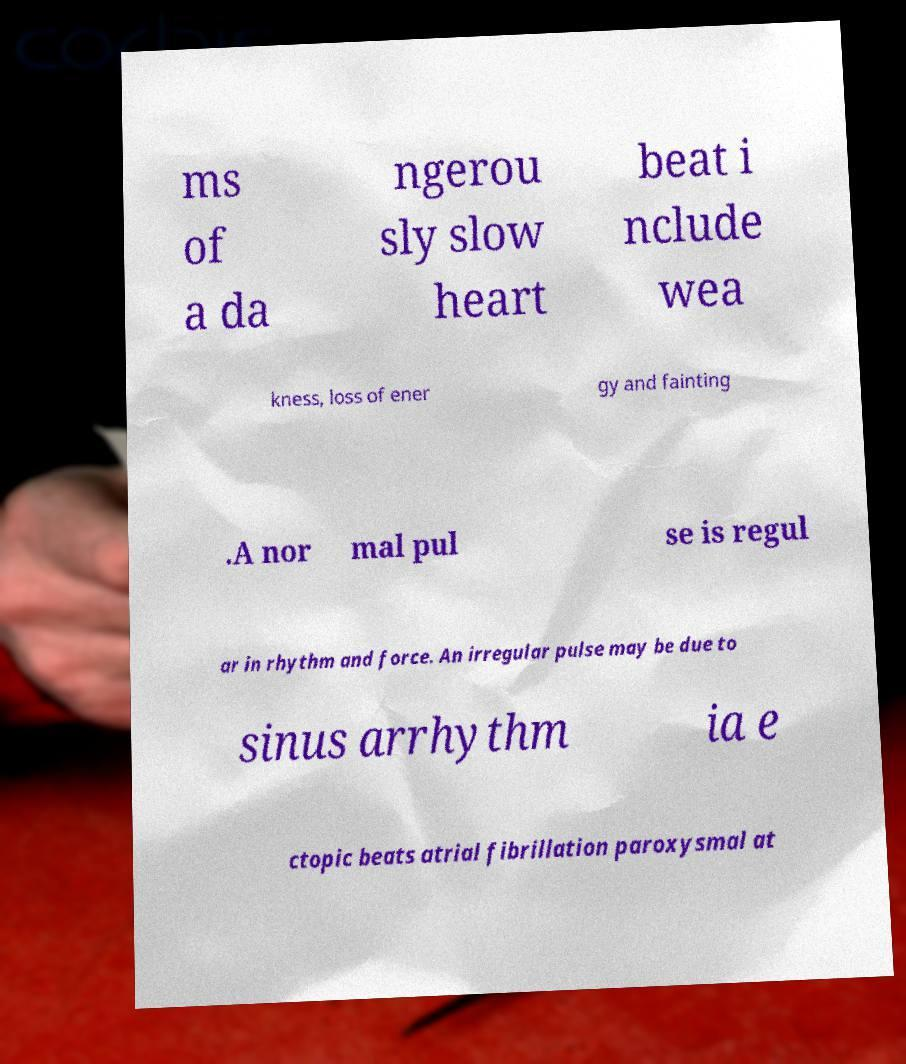For documentation purposes, I need the text within this image transcribed. Could you provide that? ms of a da ngerou sly slow heart beat i nclude wea kness, loss of ener gy and fainting .A nor mal pul se is regul ar in rhythm and force. An irregular pulse may be due to sinus arrhythm ia e ctopic beats atrial fibrillation paroxysmal at 